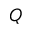<formula> <loc_0><loc_0><loc_500><loc_500>Q</formula> 